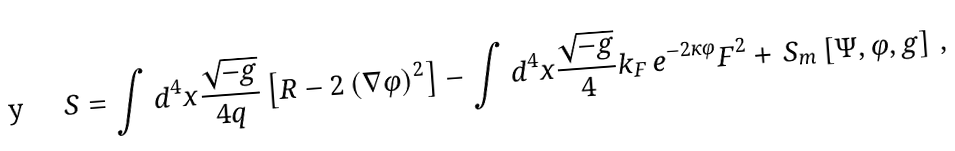<formula> <loc_0><loc_0><loc_500><loc_500>S = \int d ^ { 4 } x \frac { \sqrt { - g } } { 4 q } \left [ R - 2 \left ( \nabla \varphi \right ) ^ { 2 } \right ] - \int d ^ { 4 } x \frac { \sqrt { - g } } { 4 } k _ { F } \, e ^ { - 2 \kappa \varphi } F ^ { 2 } + \, S _ { m } \left [ \Psi , \varphi , g \right ] \, ,</formula> 